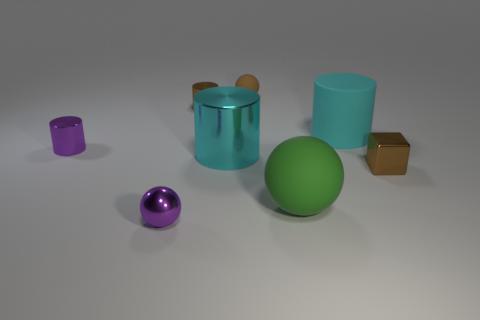Subtract all cyan metal cylinders. How many cylinders are left? 3 Subtract all green spheres. How many cyan cylinders are left? 2 Subtract 1 balls. How many balls are left? 2 Subtract all brown cylinders. How many cylinders are left? 3 Subtract all spheres. How many objects are left? 5 Add 2 tiny brown shiny things. How many objects exist? 10 Subtract all large cyan shiny objects. Subtract all tiny purple shiny cylinders. How many objects are left? 6 Add 8 green rubber things. How many green rubber things are left? 9 Add 8 big balls. How many big balls exist? 9 Subtract 1 cyan cylinders. How many objects are left? 7 